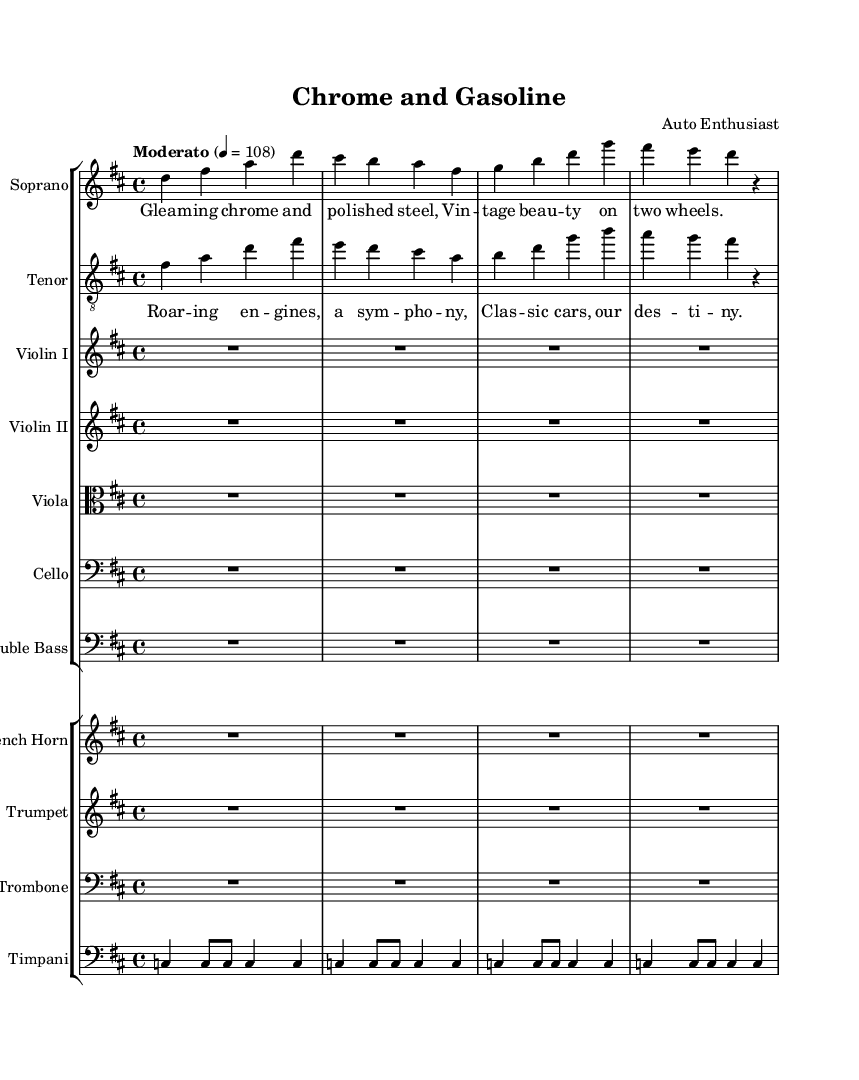What is the key signature of this music? The key signature is indicated at the beginning of the score. Here, it shows two sharps, which corresponds to the key of D major.
Answer: D major What is the time signature of this music? The time signature appears at the beginning of the score, noted as 4/4. This means there are four beats per measure, and the quarter note gets one beat.
Answer: 4/4 What is the tempo marking for this piece? The tempo marking reads "Moderato" and indicates a tempo of 108 beats per minute, which suggests a moderate speed for the performance.
Answer: Moderato, 108 Which instruments are indicated as playing in the score? The score lists various instruments, including Soprano, Tenor, Violin I, Violin II, Viola, Cello, Double Bass, French Horn, Trumpet, Trombone, and Timpani. This demonstrates a rich orchestration typical for an opera setting.
Answer: Soprano, Tenor, Violin I, Violin II, Viola, Cello, Double Bass, French Horn, Trumpet, Trombone, Timpani What is the lyrical theme of the soprano part? The lyrics for the soprano part evoke imagery of vintage beauty and polished vehicles, as indicated by the text "Gleaming chrome and polished steel, Vintage beauty on two wheels." This theme connects to the opera’s central props of vintage cars and classic motorcycles.
Answer: Vintage beauty on two wheels Identify the primary theme of the tenor lyrics. The tenor lyrics reflect a celebration of roaring engines and classic cars, encapsulating the spirit of classic vehicles as noted in the lines "Roaring engines, a symphony, Classic cars, our destiny." This illustrates the opera's focus.
Answer: Classic cars, our destiny 